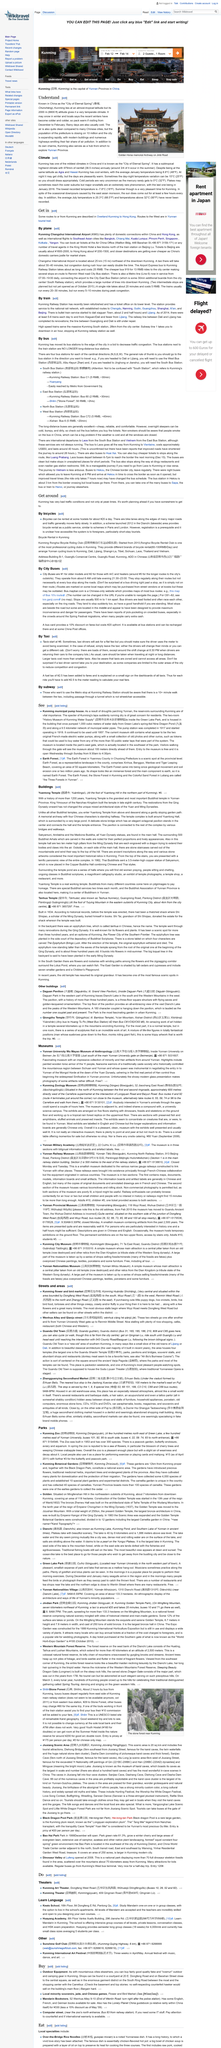Outline some significant characteristics in this image. Kunming is located at an altitude of 2000 meters. Kunming is known as the 'City of Eternal Spring' in China, renowned for its mild and pleasant climate throughout the year. 